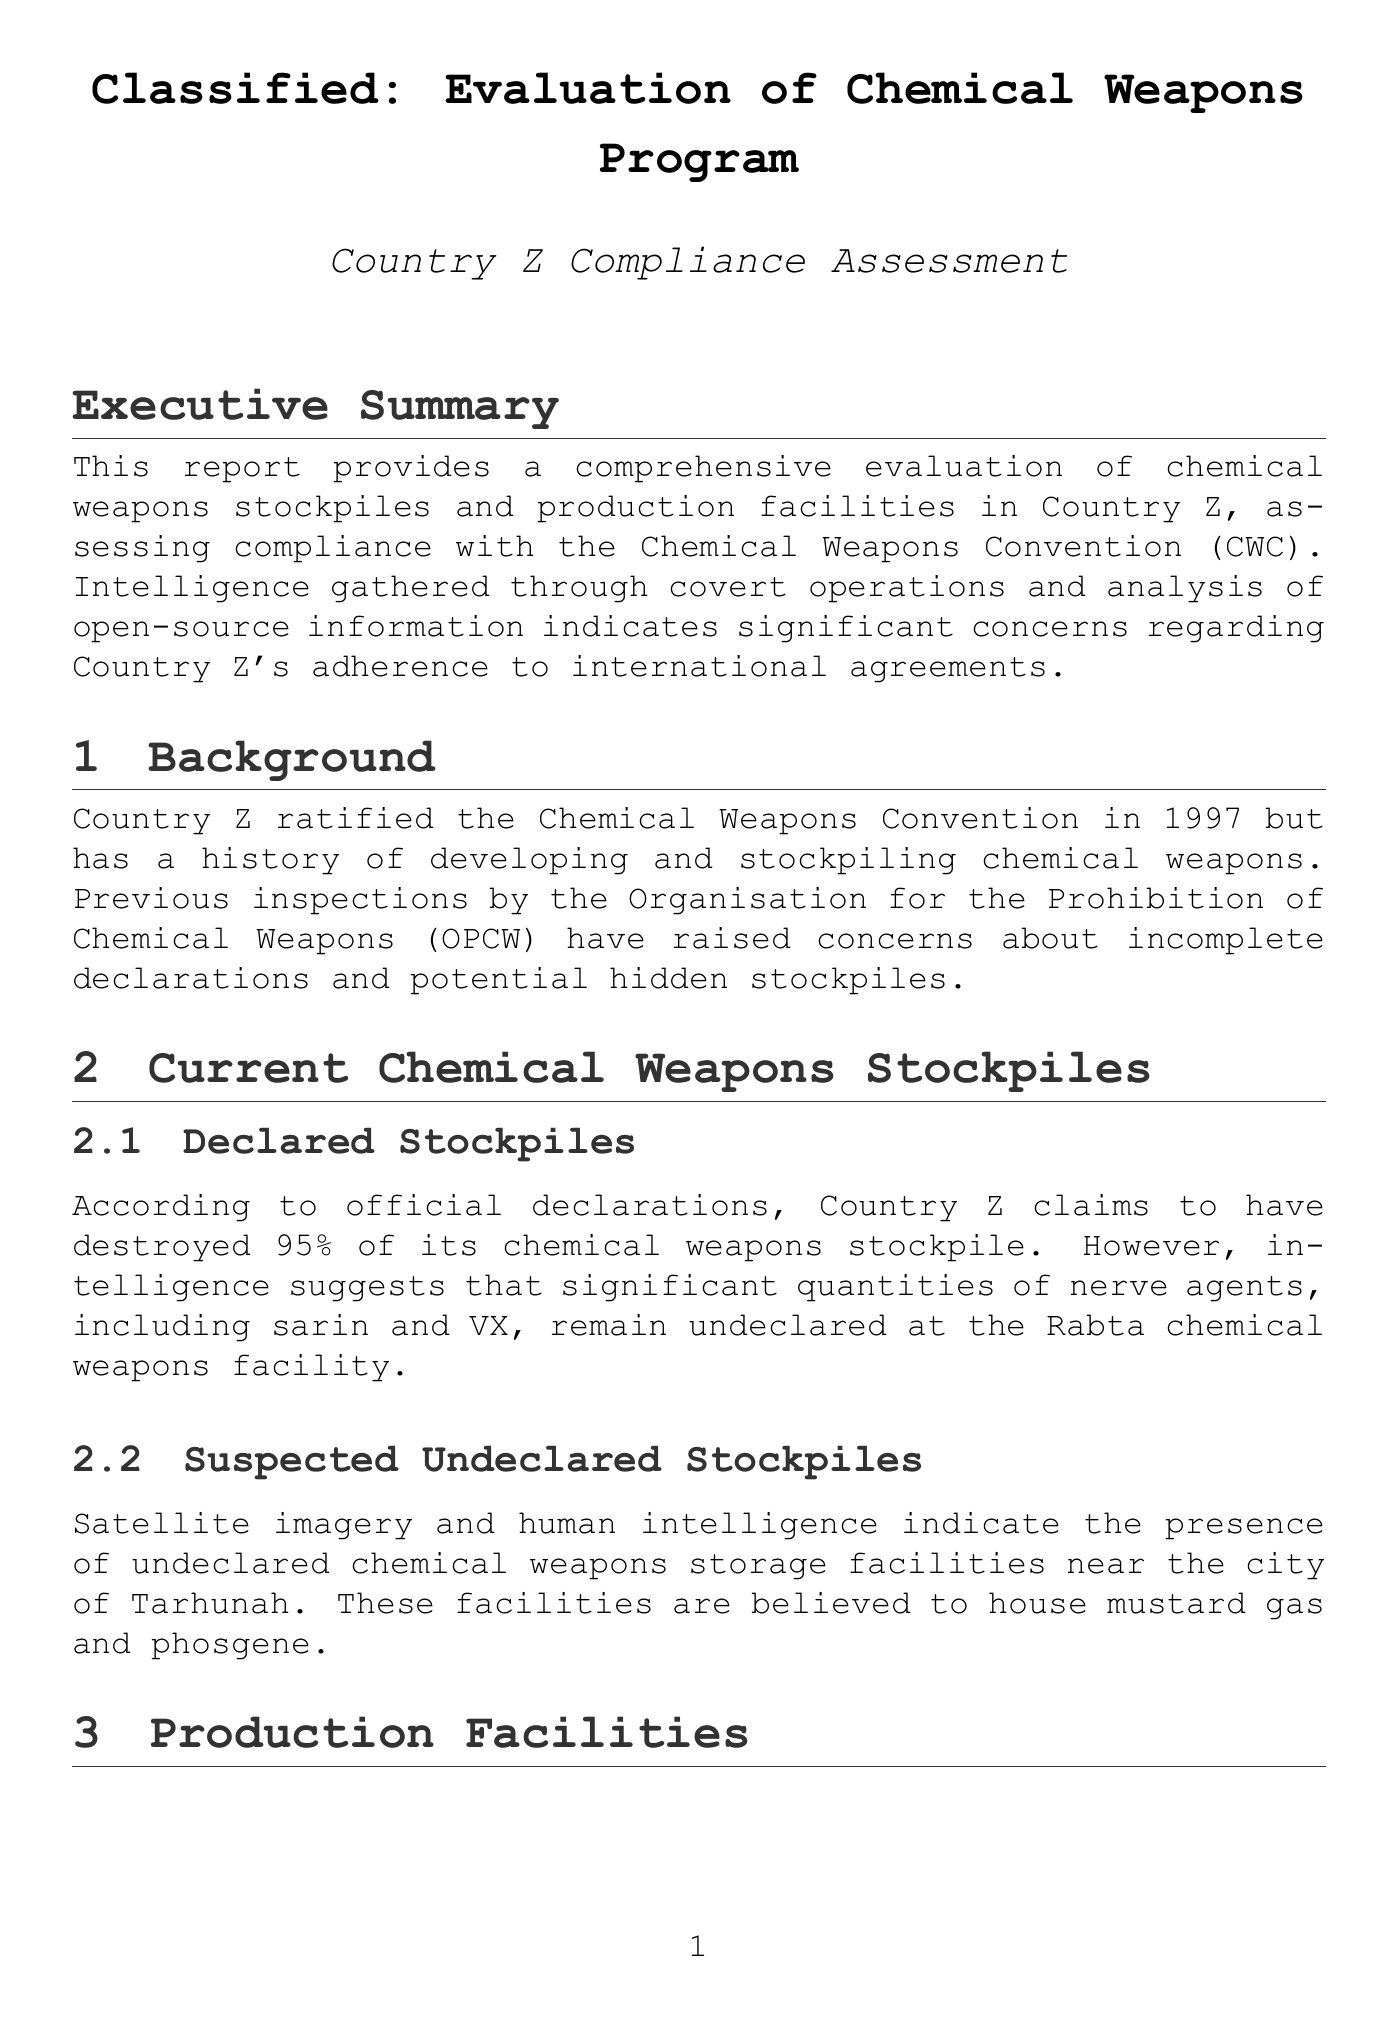What year did Country Z ratify the Chemical Weapons Convention? The document states that Country Z ratified the Chemical Weapons Convention in 1997.
Answer: 1997 What percentage of its chemical weapons stockpile does Country Z claim to have destroyed? According to the report, Country Z claims to have destroyed 95% of its chemical weapons stockpile.
Answer: 95% What are the names of the two suspected undeclared chemical agents stored near Tarhunah? The report indicates that mustard gas and phosgene are believed to be housed at the undeclared facilities near Tarhunah.
Answer: Mustard gas and phosgene Which facility is identified as a clandestine production facility? The report highlights a covert chemical weapons production facility located in an underground complex near Sabha as the clandestine production facility.
Answer: Sabha Underground Complex What is the main compliance issue highlighted in the report regarding Country Z? The document states that a key area of non-compliance includes failure to declare all chemical weapons stockpiles.
Answer: Failure to declare all chemical weapons stockpiles Who is the head of Country Z's chemical weapons program? The report lists Dr. Mahmoud Al-Fitouri as the head of Country Z's chemical weapons program.
Answer: Dr. Mahmoud Al-Fitouri What does the Pharma-150 plant in Rabta supposedly produce? The report mentions that the Pharma-150 plant has been ostensibly converted for civilian pharmaceutical manufacturing.
Answer: Civilian pharmaceutical manufacturing What is recommended to enhance surveillance of suspected chemical weapons facilities? The report suggests enhancing surveillance of suspected chemical weapons facilities, particularly the underground complex near Sabha.
Answer: Underground complex near Sabha 